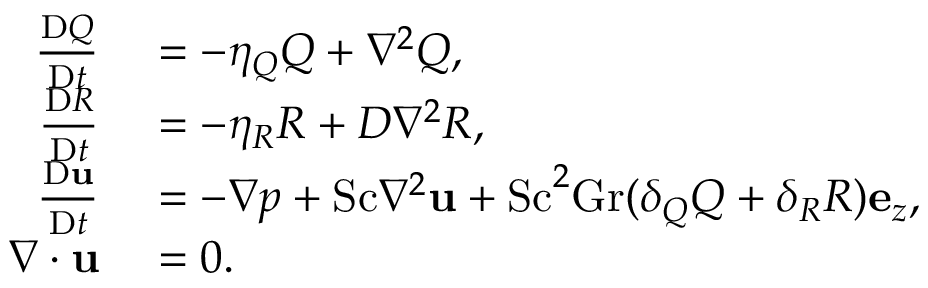<formula> <loc_0><loc_0><loc_500><loc_500>\begin{array} { r l } { \frac { D Q } { D t } } & = - \eta _ { Q } Q + \nabla ^ { 2 } Q , } \\ { \frac { D R } { D t } } & = - \eta _ { R } R + D \nabla ^ { 2 } R , } \\ { \frac { D u } { D t } } & = - \nabla p + S c \nabla ^ { 2 } u + S c ^ { 2 } G r ( \delta _ { Q } Q + \delta _ { R } R ) e _ { z } , } \\ { \nabla \cdot u } & = 0 . } \end{array}</formula> 